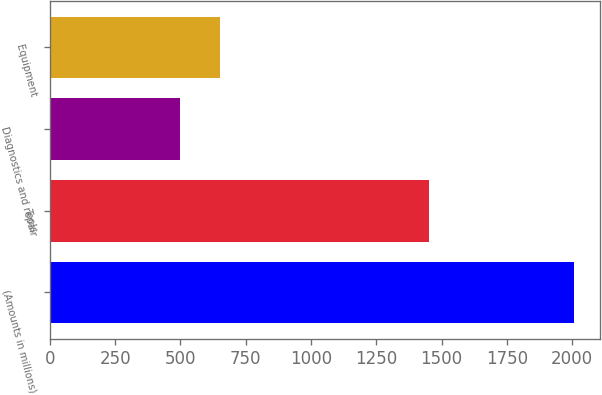<chart> <loc_0><loc_0><loc_500><loc_500><bar_chart><fcel>(Amounts in millions)<fcel>Tools<fcel>Diagnostics and repair<fcel>Equipment<nl><fcel>2006<fcel>1453.1<fcel>499.5<fcel>650.15<nl></chart> 